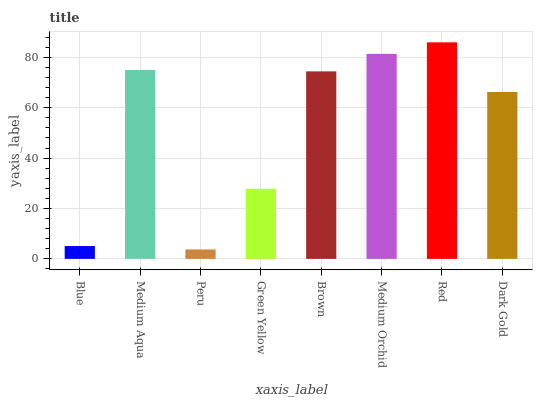Is Peru the minimum?
Answer yes or no. Yes. Is Red the maximum?
Answer yes or no. Yes. Is Medium Aqua the minimum?
Answer yes or no. No. Is Medium Aqua the maximum?
Answer yes or no. No. Is Medium Aqua greater than Blue?
Answer yes or no. Yes. Is Blue less than Medium Aqua?
Answer yes or no. Yes. Is Blue greater than Medium Aqua?
Answer yes or no. No. Is Medium Aqua less than Blue?
Answer yes or no. No. Is Brown the high median?
Answer yes or no. Yes. Is Dark Gold the low median?
Answer yes or no. Yes. Is Medium Orchid the high median?
Answer yes or no. No. Is Red the low median?
Answer yes or no. No. 